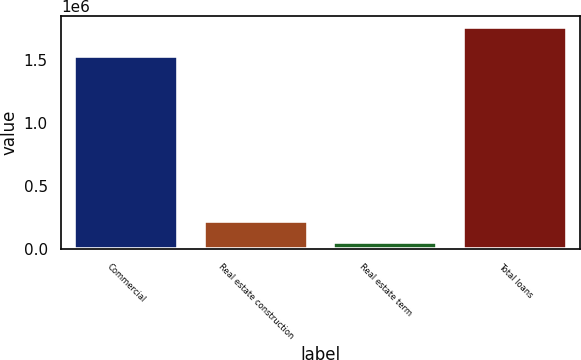Convert chart. <chart><loc_0><loc_0><loc_500><loc_500><bar_chart><fcel>Commercial<fcel>Real estate construction<fcel>Real estate term<fcel>Total loans<nl><fcel>1.53684e+06<fcel>222545<fcel>50935<fcel>1.76704e+06<nl></chart> 